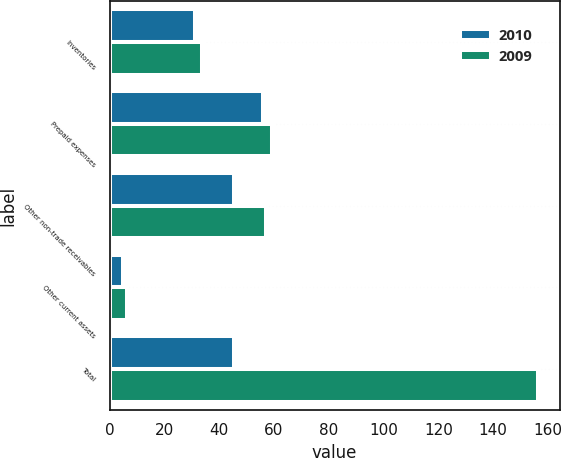Convert chart to OTSL. <chart><loc_0><loc_0><loc_500><loc_500><stacked_bar_chart><ecel><fcel>Inventories<fcel>Prepaid expenses<fcel>Other non-trade receivables<fcel>Other current assets<fcel>Total<nl><fcel>2010<fcel>31.3<fcel>55.9<fcel>45.4<fcel>5<fcel>45.4<nl><fcel>2009<fcel>33.7<fcel>59.3<fcel>57.1<fcel>6.4<fcel>156.5<nl></chart> 